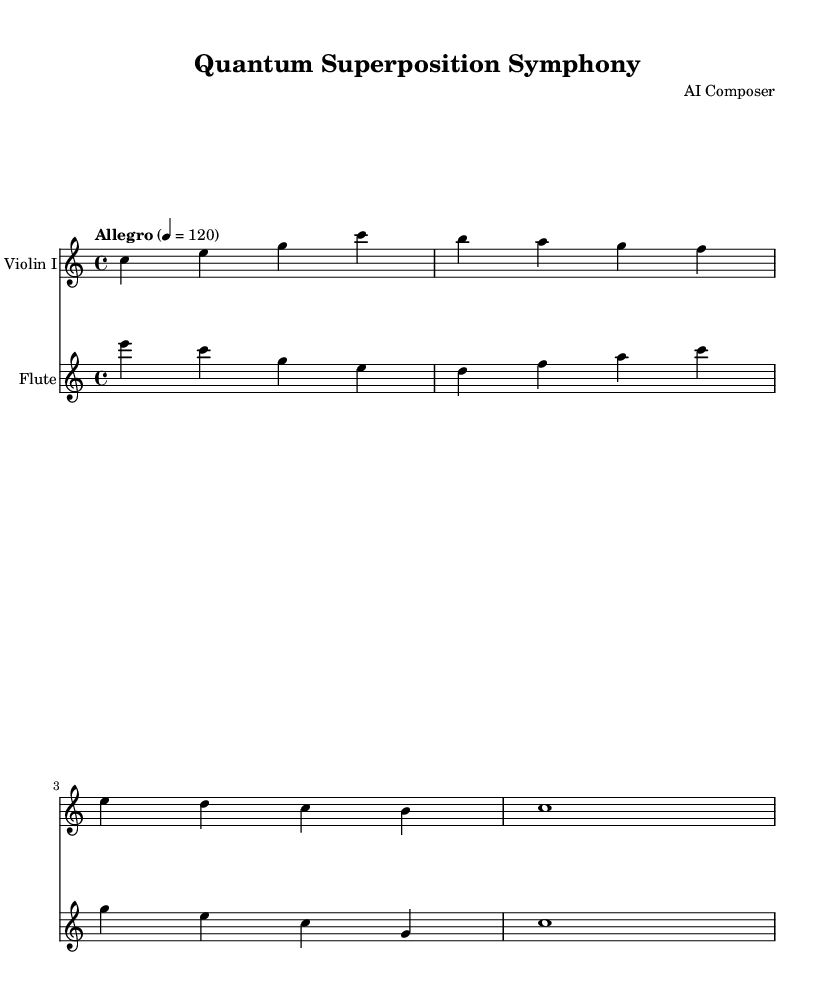What is the key signature of this music? The key signature indicates the key of the piece, which is C major. C major has no sharps or flats in its key signature.
Answer: C major What is the time signature of this music? The time signature is indicated at the beginning of the score and is shown as 4/4. This means there are four beats in each measure and the quarter note gets one beat.
Answer: 4/4 What is the tempo marking for this symphony? The tempo marking in the score specifies the speed of the music. It states "Allegro," which is a term used to describe a fast tempo.
Answer: Allegro How many measures are present in the Violin I part? By counting the measures in the Violin I part, we see that there are four measures. Each measure is separated by a vertical line in the sheet music.
Answer: 4 Which instruments are featured in this symphony? The instruments are listed at the beginning of each staff. The score includes Violin I and Flute, as denoted in their respective staves.
Answer: Violin I and Flute What notes are played in the first measure of the Flute part? The first measure of the Flute part contains the notes E, C, G, and E, indicated by their respective note symbols stacked on top of each other.
Answer: E, C, G, E What rhythmic value does the last note in the Violin I part have? The last note in the Violin I part is a whole note, which is indicated by its shape and the fact that it occupies the entire measure without any additional notes.
Answer: Whole note 